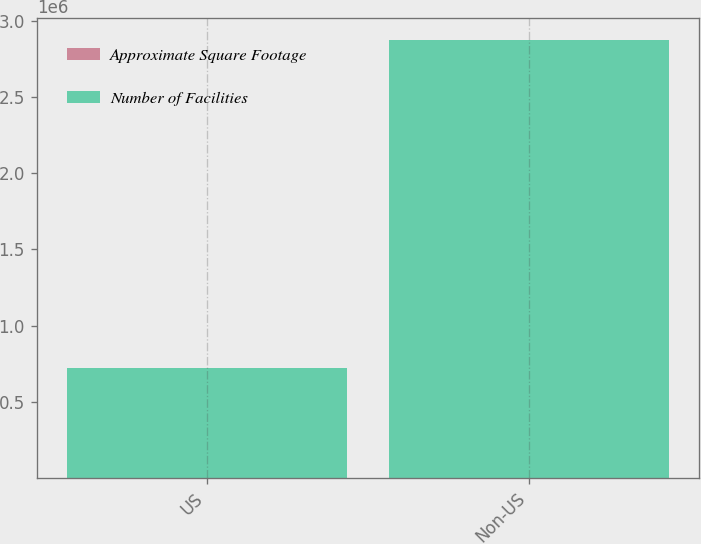Convert chart. <chart><loc_0><loc_0><loc_500><loc_500><stacked_bar_chart><ecel><fcel>US<fcel>Non-US<nl><fcel>Approximate Square Footage<fcel>4<fcel>16<nl><fcel>Number of Facilities<fcel>725000<fcel>2.874e+06<nl></chart> 